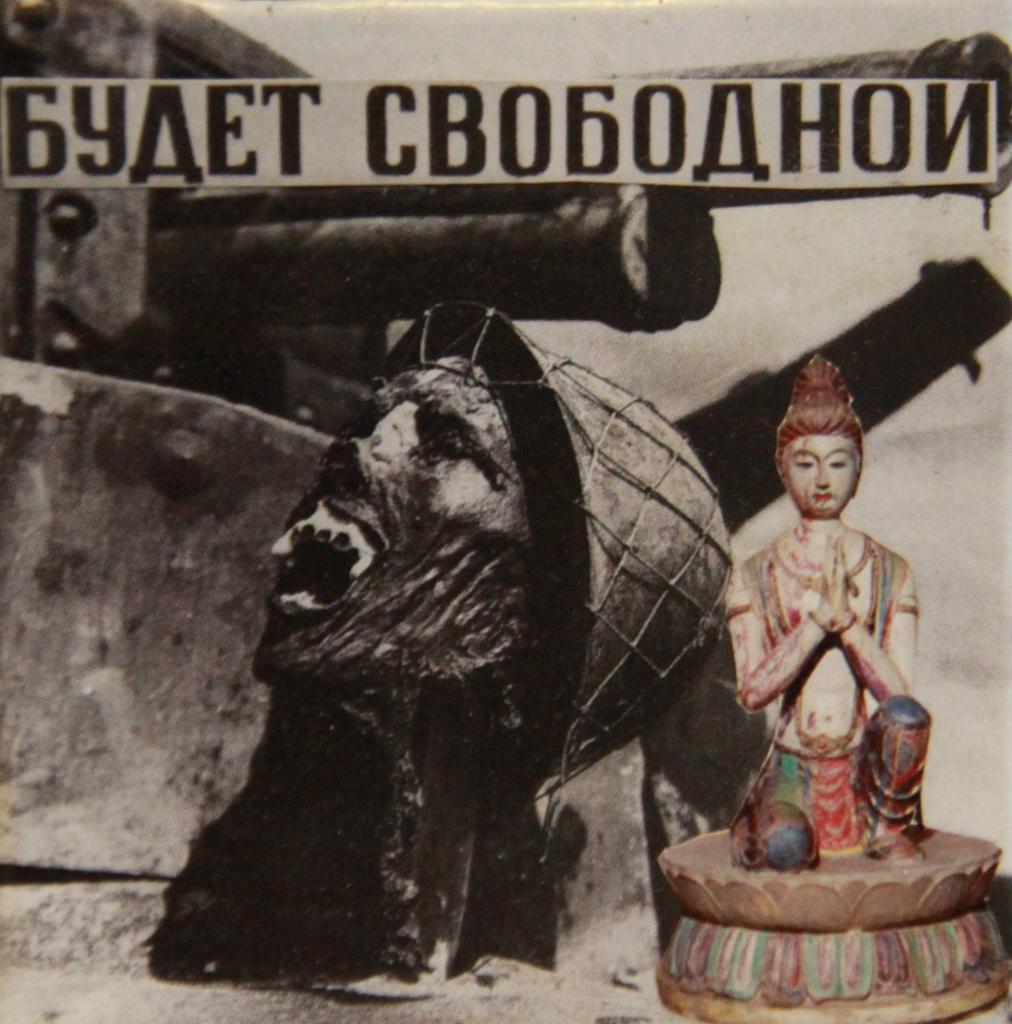How would you summarize this image in a sentence or two? In this image we can see a poster, on that there are images, and text. 